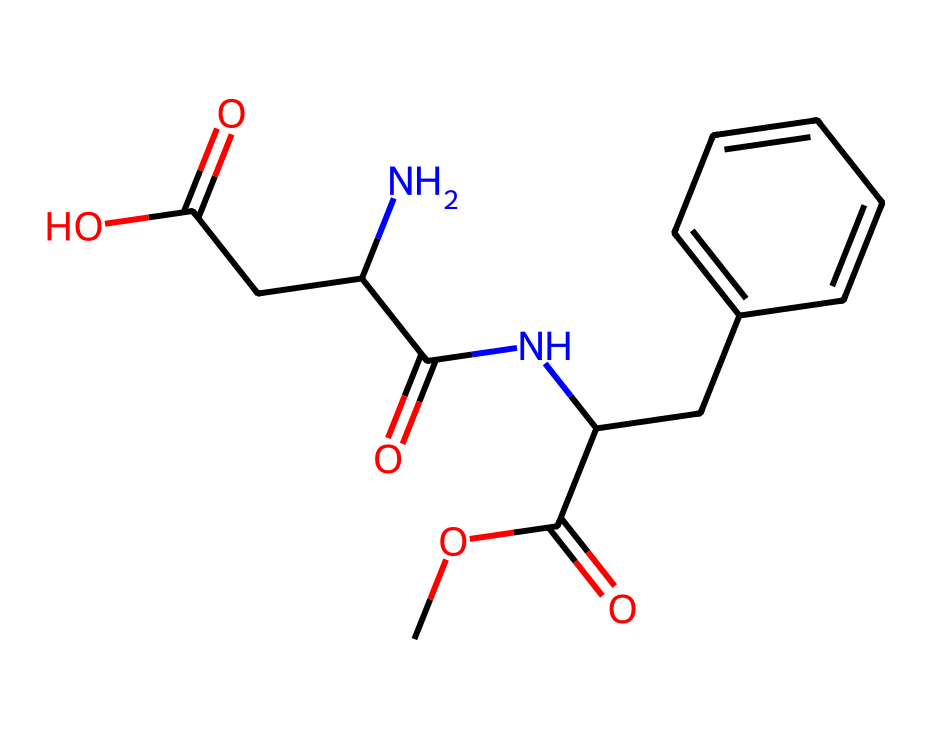What type of functional groups are present in this structure? The structure contains carboxylic acid (-COOH) and amide (-C(=O)N-) functional groups as indicated by the specific groups of atoms within the SMILES.
Answer: carboxylic acid and amide How many nitrogen atoms are in the structure? The SMILES shows one nitrogen atom (N) present within the amide group in the structure.
Answer: one What is the total number of carbon atoms in this compound? By counting the 'C' symbols in the SMILES, we can identify that there are 12 carbon atoms present in the entire structure.
Answer: twelve Does this compound have any rings in its structure? The presence of 'CC1=CC=CC=C1' indicates a six-membered aromatic ring, confirming that the compound does have a ring structure.
Answer: yes What role does this compound play in diet sodas? This compound serves as an artificial sweetener, contributing to the sweetness of diet sodas without adding significant calories.
Answer: artificial sweetener What can be inferred about the solubility of this compound? Given the presence of multiple polar functional groups like carboxylic acids and amides, it suggests a higher likelihood of solubility in water compared to nonpolar compounds.
Answer: high solubility How does the presence of the amide group influence taste perception? The amide group can enhance the sweetness and flavor profile of the compound, as many sweeteners utilize amide bonds to interact tastefully with the sweetness receptors.
Answer: enhances sweetness 